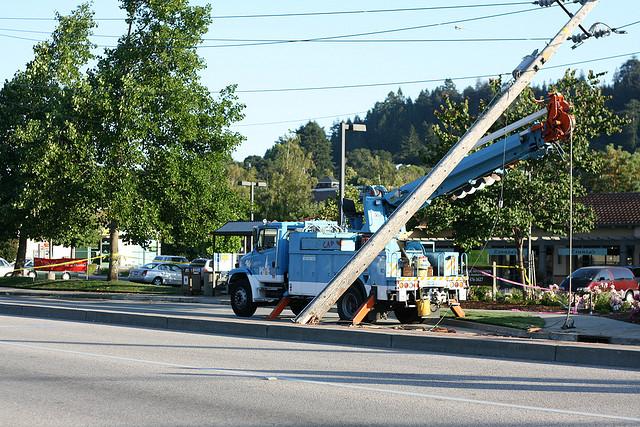What color is the truck?
Write a very short answer. Blue. What is the truck called?
Write a very short answer. Crane. Is the truck moving?
Keep it brief. No. 